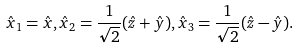Convert formula to latex. <formula><loc_0><loc_0><loc_500><loc_500>\hat { x } _ { 1 } = \hat { x } , \hat { x } _ { 2 } = \frac { 1 } { \sqrt { 2 } } ( \hat { z } + \hat { y } ) , \hat { x } _ { 3 } = \frac { 1 } { \sqrt { 2 } } ( \hat { z } - \hat { y } ) .</formula> 